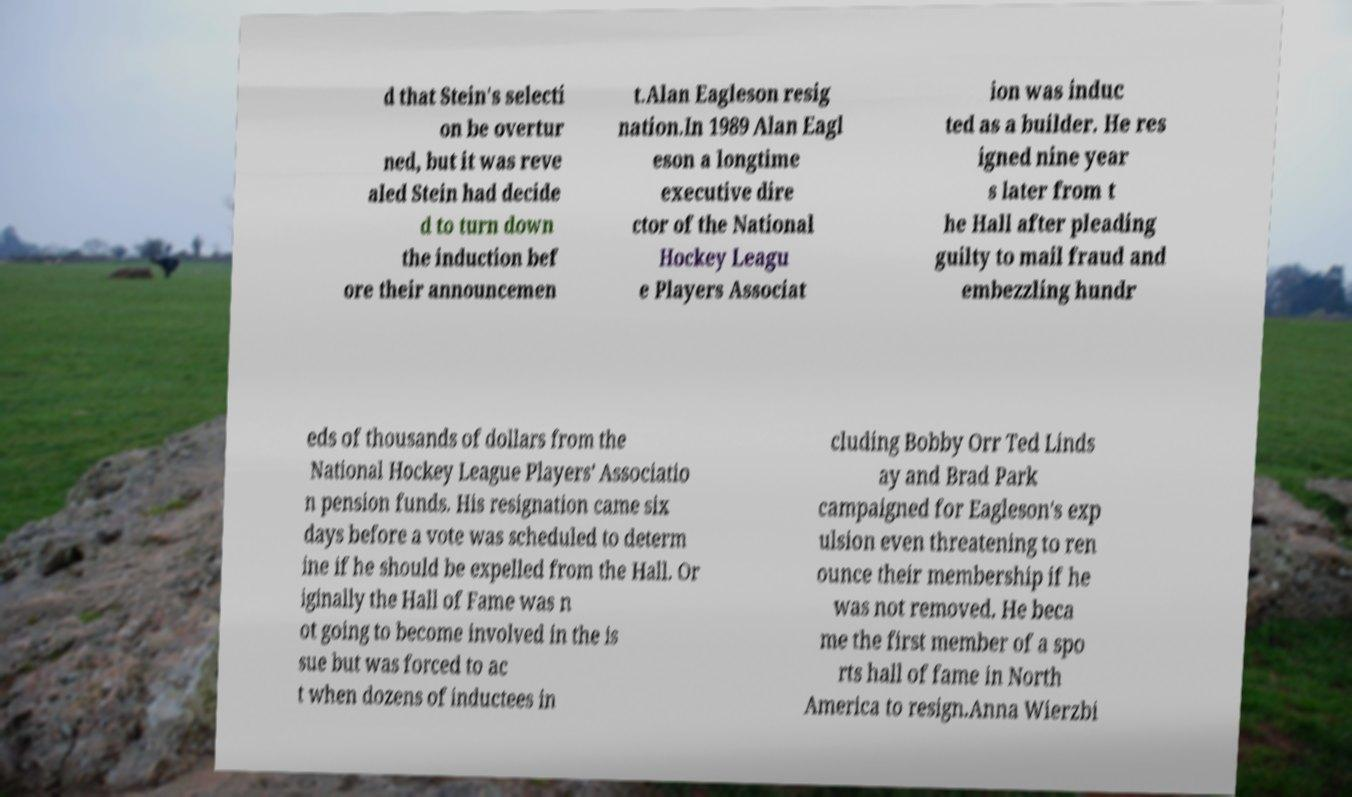Could you extract and type out the text from this image? d that Stein's selecti on be overtur ned, but it was reve aled Stein had decide d to turn down the induction bef ore their announcemen t.Alan Eagleson resig nation.In 1989 Alan Eagl eson a longtime executive dire ctor of the National Hockey Leagu e Players Associat ion was induc ted as a builder. He res igned nine year s later from t he Hall after pleading guilty to mail fraud and embezzling hundr eds of thousands of dollars from the National Hockey League Players' Associatio n pension funds. His resignation came six days before a vote was scheduled to determ ine if he should be expelled from the Hall. Or iginally the Hall of Fame was n ot going to become involved in the is sue but was forced to ac t when dozens of inductees in cluding Bobby Orr Ted Linds ay and Brad Park campaigned for Eagleson's exp ulsion even threatening to ren ounce their membership if he was not removed. He beca me the first member of a spo rts hall of fame in North America to resign.Anna Wierzbi 